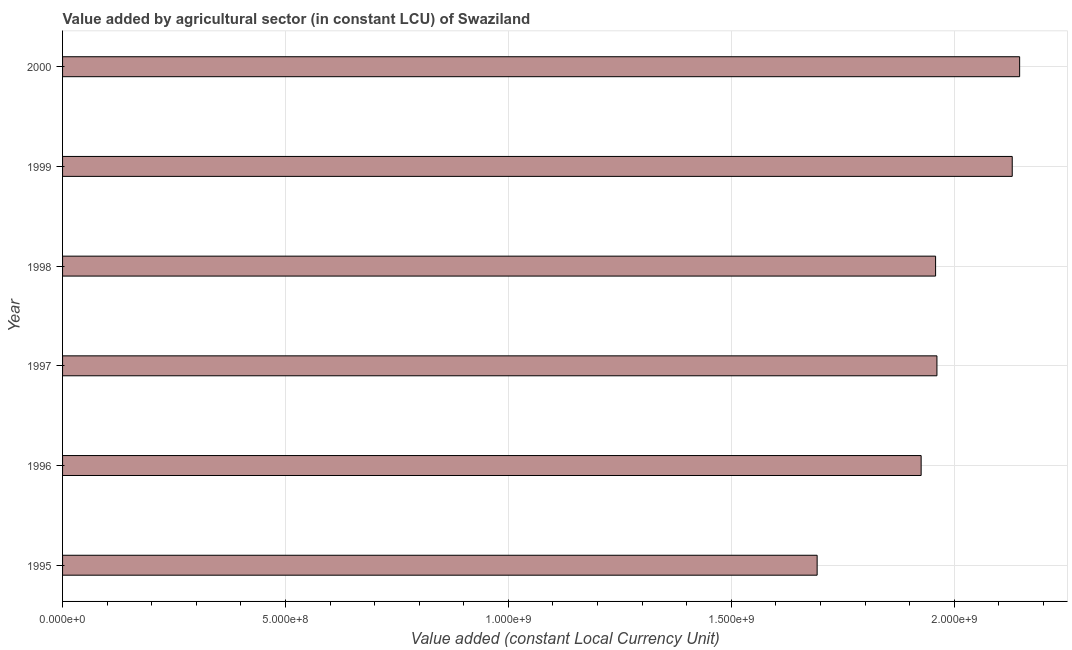Does the graph contain any zero values?
Your response must be concise. No. Does the graph contain grids?
Offer a terse response. Yes. What is the title of the graph?
Provide a succinct answer. Value added by agricultural sector (in constant LCU) of Swaziland. What is the label or title of the X-axis?
Make the answer very short. Value added (constant Local Currency Unit). What is the value added by agriculture sector in 1999?
Provide a succinct answer. 2.13e+09. Across all years, what is the maximum value added by agriculture sector?
Offer a very short reply. 2.15e+09. Across all years, what is the minimum value added by agriculture sector?
Your response must be concise. 1.69e+09. What is the sum of the value added by agriculture sector?
Provide a short and direct response. 1.18e+1. What is the difference between the value added by agriculture sector in 1995 and 2000?
Your response must be concise. -4.54e+08. What is the average value added by agriculture sector per year?
Your response must be concise. 1.97e+09. What is the median value added by agriculture sector?
Offer a very short reply. 1.96e+09. In how many years, is the value added by agriculture sector greater than 2100000000 LCU?
Ensure brevity in your answer.  2. Do a majority of the years between 1999 and 1998 (inclusive) have value added by agriculture sector greater than 400000000 LCU?
Your response must be concise. No. What is the ratio of the value added by agriculture sector in 1996 to that in 1999?
Your answer should be very brief. 0.9. Is the value added by agriculture sector in 1995 less than that in 1999?
Give a very brief answer. Yes. Is the difference between the value added by agriculture sector in 1996 and 1998 greater than the difference between any two years?
Make the answer very short. No. What is the difference between the highest and the second highest value added by agriculture sector?
Give a very brief answer. 1.66e+07. What is the difference between the highest and the lowest value added by agriculture sector?
Your answer should be very brief. 4.54e+08. How many bars are there?
Provide a succinct answer. 6. What is the difference between two consecutive major ticks on the X-axis?
Your answer should be very brief. 5.00e+08. What is the Value added (constant Local Currency Unit) of 1995?
Your answer should be very brief. 1.69e+09. What is the Value added (constant Local Currency Unit) in 1996?
Offer a terse response. 1.93e+09. What is the Value added (constant Local Currency Unit) of 1997?
Provide a short and direct response. 1.96e+09. What is the Value added (constant Local Currency Unit) of 1998?
Offer a very short reply. 1.96e+09. What is the Value added (constant Local Currency Unit) of 1999?
Ensure brevity in your answer.  2.13e+09. What is the Value added (constant Local Currency Unit) in 2000?
Keep it short and to the point. 2.15e+09. What is the difference between the Value added (constant Local Currency Unit) in 1995 and 1996?
Offer a very short reply. -2.33e+08. What is the difference between the Value added (constant Local Currency Unit) in 1995 and 1997?
Provide a succinct answer. -2.69e+08. What is the difference between the Value added (constant Local Currency Unit) in 1995 and 1998?
Keep it short and to the point. -2.66e+08. What is the difference between the Value added (constant Local Currency Unit) in 1995 and 1999?
Offer a terse response. -4.38e+08. What is the difference between the Value added (constant Local Currency Unit) in 1995 and 2000?
Your answer should be very brief. -4.54e+08. What is the difference between the Value added (constant Local Currency Unit) in 1996 and 1997?
Provide a short and direct response. -3.54e+07. What is the difference between the Value added (constant Local Currency Unit) in 1996 and 1998?
Offer a very short reply. -3.24e+07. What is the difference between the Value added (constant Local Currency Unit) in 1996 and 1999?
Offer a very short reply. -2.04e+08. What is the difference between the Value added (constant Local Currency Unit) in 1996 and 2000?
Your response must be concise. -2.21e+08. What is the difference between the Value added (constant Local Currency Unit) in 1997 and 1998?
Your answer should be very brief. 3.04e+06. What is the difference between the Value added (constant Local Currency Unit) in 1997 and 1999?
Provide a short and direct response. -1.69e+08. What is the difference between the Value added (constant Local Currency Unit) in 1997 and 2000?
Offer a terse response. -1.85e+08. What is the difference between the Value added (constant Local Currency Unit) in 1998 and 1999?
Your answer should be compact. -1.72e+08. What is the difference between the Value added (constant Local Currency Unit) in 1998 and 2000?
Provide a short and direct response. -1.89e+08. What is the difference between the Value added (constant Local Currency Unit) in 1999 and 2000?
Your response must be concise. -1.66e+07. What is the ratio of the Value added (constant Local Currency Unit) in 1995 to that in 1996?
Provide a succinct answer. 0.88. What is the ratio of the Value added (constant Local Currency Unit) in 1995 to that in 1997?
Your answer should be compact. 0.86. What is the ratio of the Value added (constant Local Currency Unit) in 1995 to that in 1998?
Your response must be concise. 0.86. What is the ratio of the Value added (constant Local Currency Unit) in 1995 to that in 1999?
Your answer should be compact. 0.8. What is the ratio of the Value added (constant Local Currency Unit) in 1995 to that in 2000?
Your answer should be compact. 0.79. What is the ratio of the Value added (constant Local Currency Unit) in 1996 to that in 1997?
Make the answer very short. 0.98. What is the ratio of the Value added (constant Local Currency Unit) in 1996 to that in 1999?
Provide a succinct answer. 0.9. What is the ratio of the Value added (constant Local Currency Unit) in 1996 to that in 2000?
Make the answer very short. 0.9. What is the ratio of the Value added (constant Local Currency Unit) in 1997 to that in 1999?
Make the answer very short. 0.92. What is the ratio of the Value added (constant Local Currency Unit) in 1997 to that in 2000?
Give a very brief answer. 0.91. What is the ratio of the Value added (constant Local Currency Unit) in 1998 to that in 1999?
Your answer should be compact. 0.92. What is the ratio of the Value added (constant Local Currency Unit) in 1998 to that in 2000?
Offer a very short reply. 0.91. 